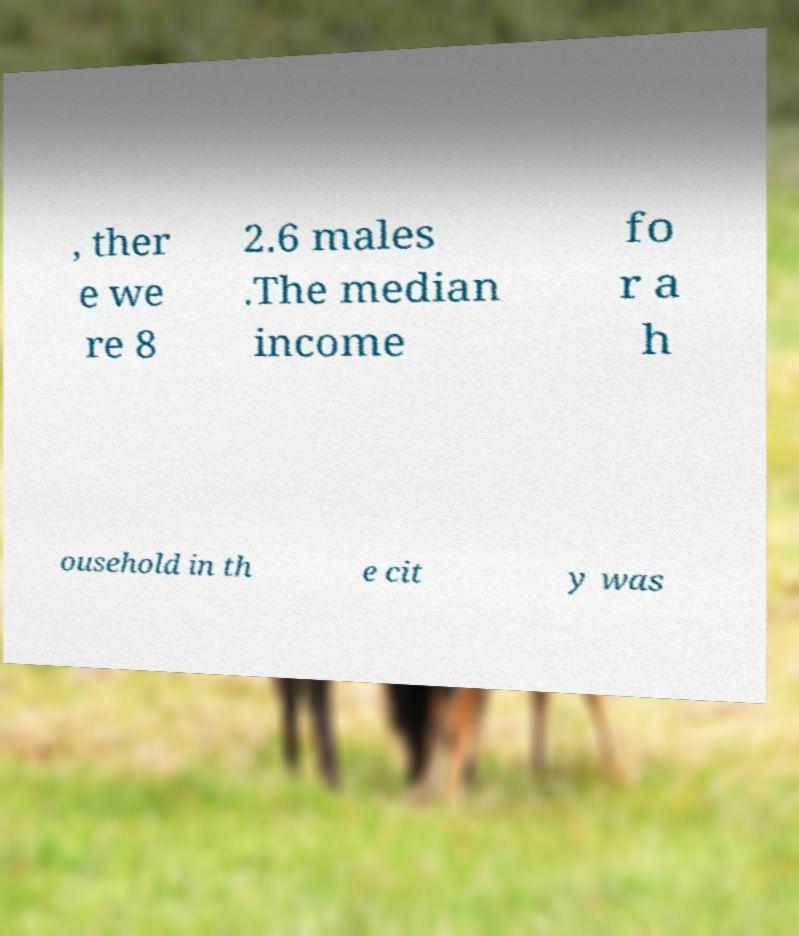Could you assist in decoding the text presented in this image and type it out clearly? , ther e we re 8 2.6 males .The median income fo r a h ousehold in th e cit y was 